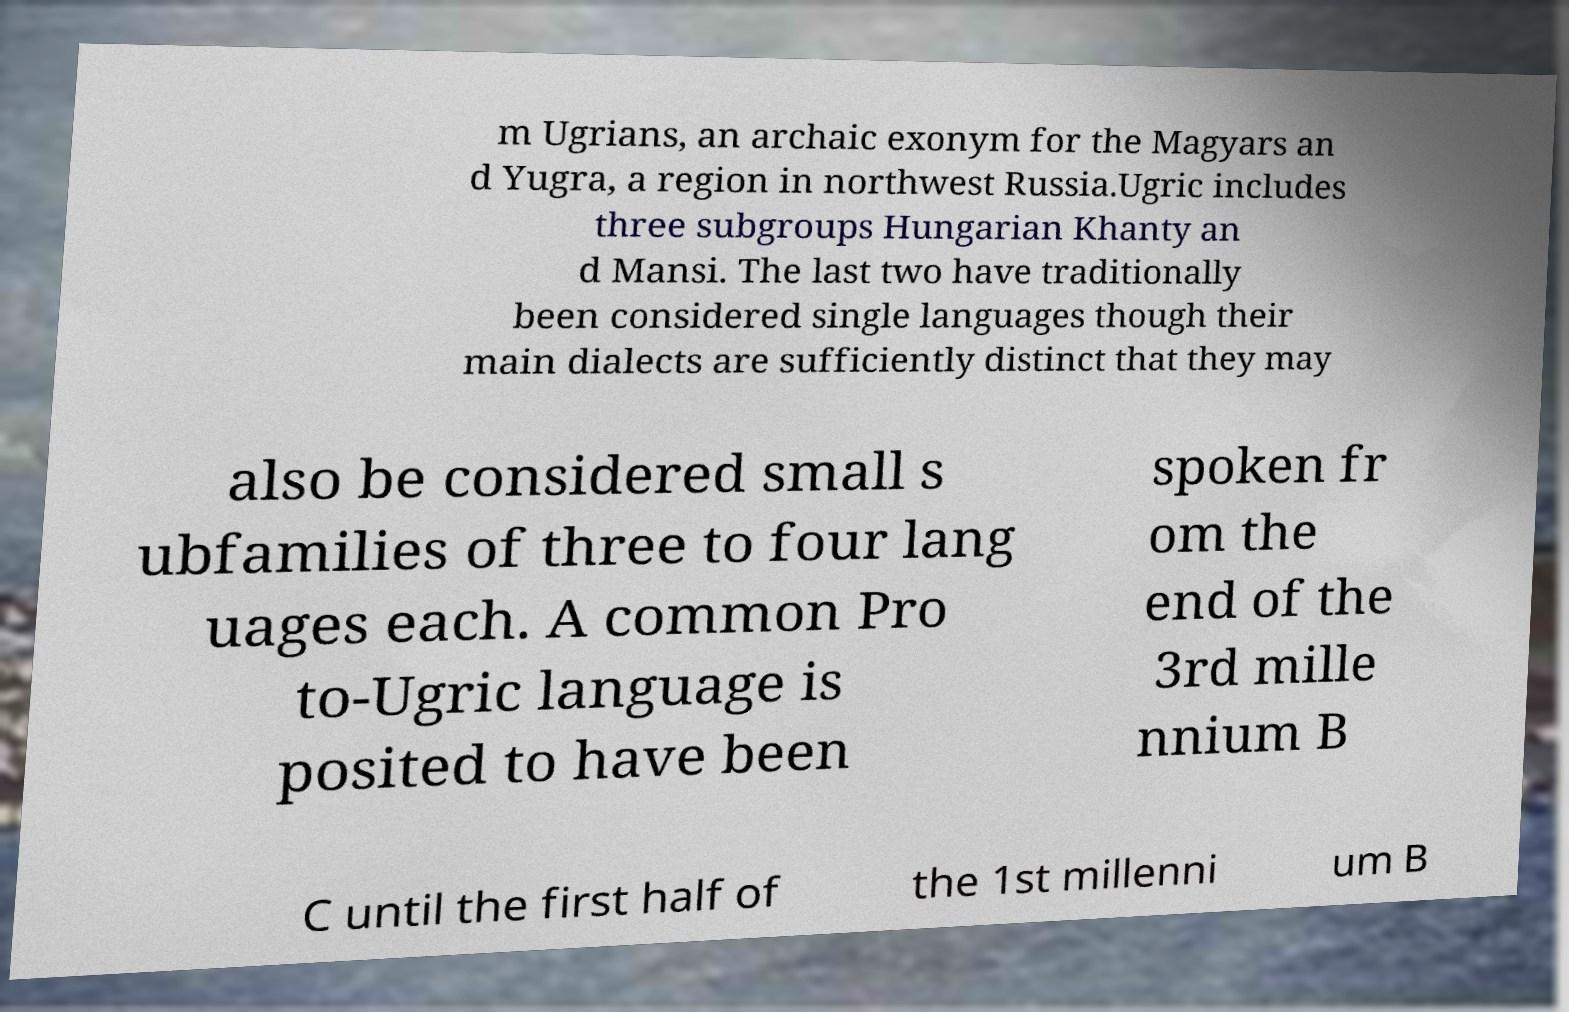Can you read and provide the text displayed in the image?This photo seems to have some interesting text. Can you extract and type it out for me? m Ugrians, an archaic exonym for the Magyars an d Yugra, a region in northwest Russia.Ugric includes three subgroups Hungarian Khanty an d Mansi. The last two have traditionally been considered single languages though their main dialects are sufficiently distinct that they may also be considered small s ubfamilies of three to four lang uages each. A common Pro to-Ugric language is posited to have been spoken fr om the end of the 3rd mille nnium B C until the first half of the 1st millenni um B 